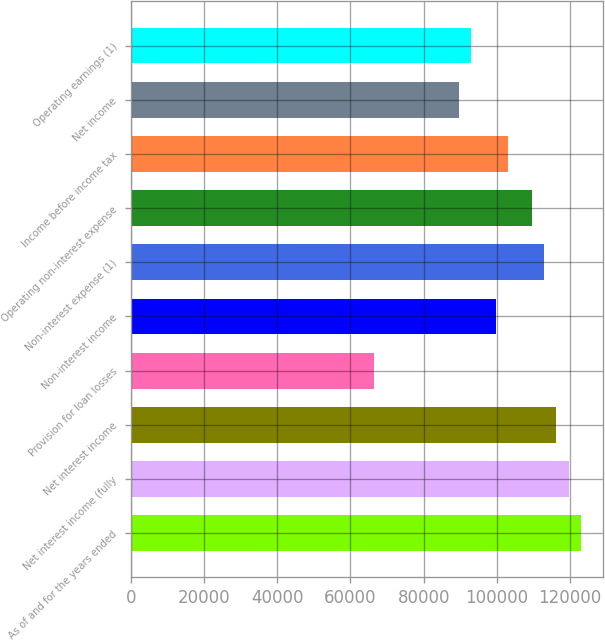Convert chart to OTSL. <chart><loc_0><loc_0><loc_500><loc_500><bar_chart><fcel>As of and for the years ended<fcel>Net interest income (fully<fcel>Net interest income<fcel>Provision for loan losses<fcel>Non-interest income<fcel>Non-interest expense (1)<fcel>Operating non-interest expense<fcel>Income before income tax<fcel>Net income<fcel>Operating earnings (1)<nl><fcel>122891<fcel>119570<fcel>116248<fcel>66427.8<fcel>99641.6<fcel>112927<fcel>109606<fcel>102963<fcel>89677.4<fcel>92998.8<nl></chart> 